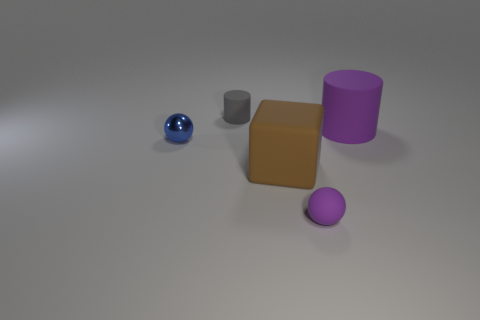Add 4 cylinders. How many objects exist? 9 Subtract all cylinders. How many objects are left? 3 Subtract all large shiny cylinders. Subtract all matte cylinders. How many objects are left? 3 Add 1 gray things. How many gray things are left? 2 Add 2 small brown shiny cubes. How many small brown shiny cubes exist? 2 Subtract 0 gray blocks. How many objects are left? 5 